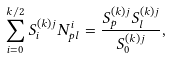Convert formula to latex. <formula><loc_0><loc_0><loc_500><loc_500>\sum _ { i = 0 } ^ { k / 2 } S _ { i } ^ { ( k ) j } N _ { p l } ^ { i } = \frac { S _ { p } ^ { ( k ) j } S _ { l } ^ { ( k ) j } } { S _ { 0 } ^ { ( k ) j } } ,</formula> 